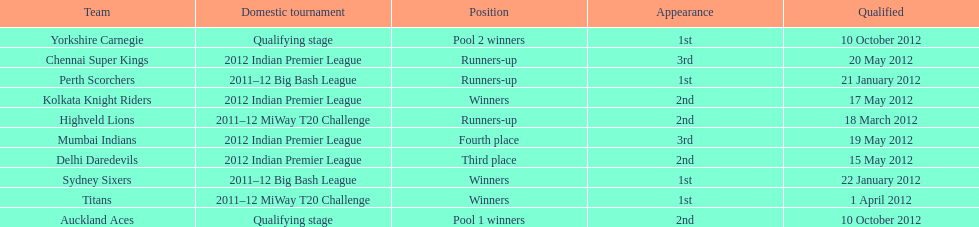Which teams were the last to qualify? Auckland Aces, Yorkshire Carnegie. 